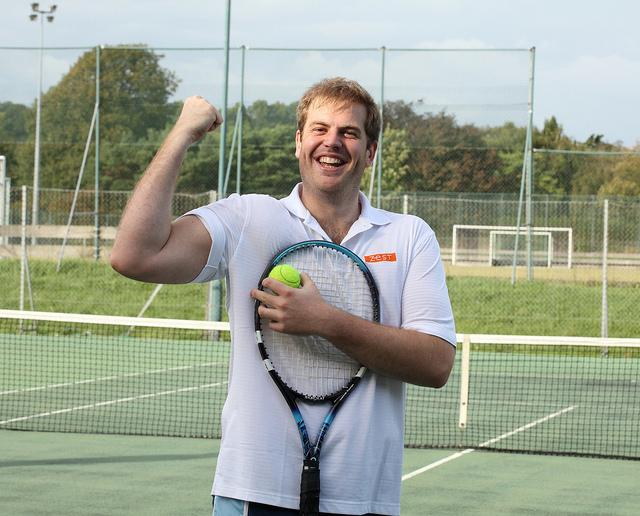What does the man show off here? Please explain your reasoning. bicep. The man has biceps. 